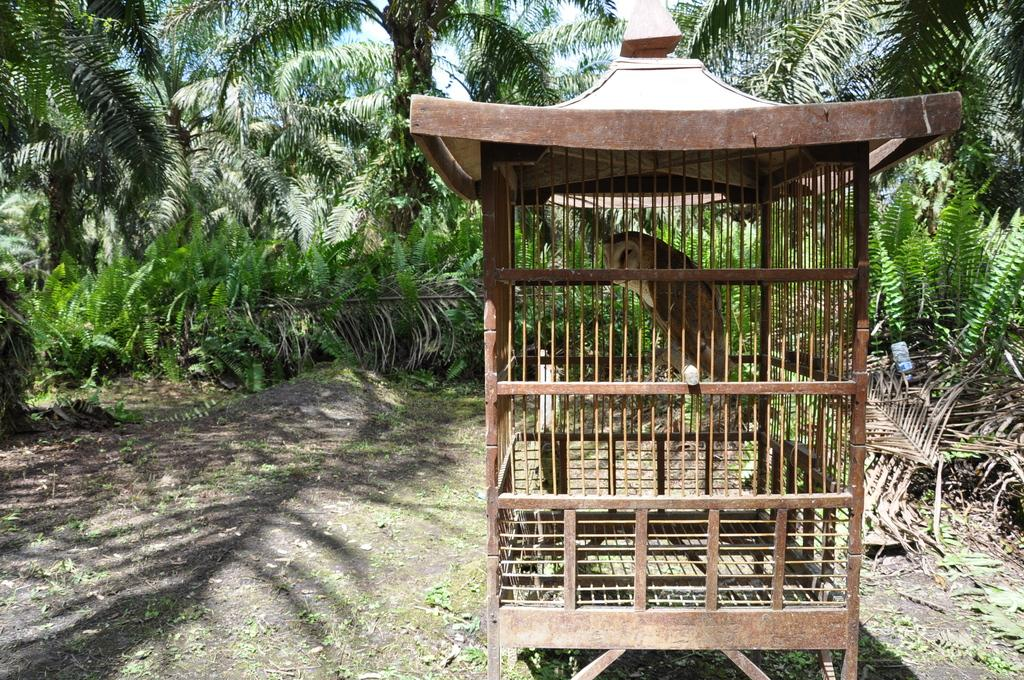Where was the image taken? The image was clicked outside. What can be seen in the middle of the image? There are trees and a cage in the middle of the image. What is inside the cage? There is a bird in the cage. What type of science experiment is being conducted in the image? There is no science experiment present in the image; it features trees, a cage, and a bird. Can you tell me how much money is being exchanged in the image? There is no mention of money or any financial transaction in the image. 